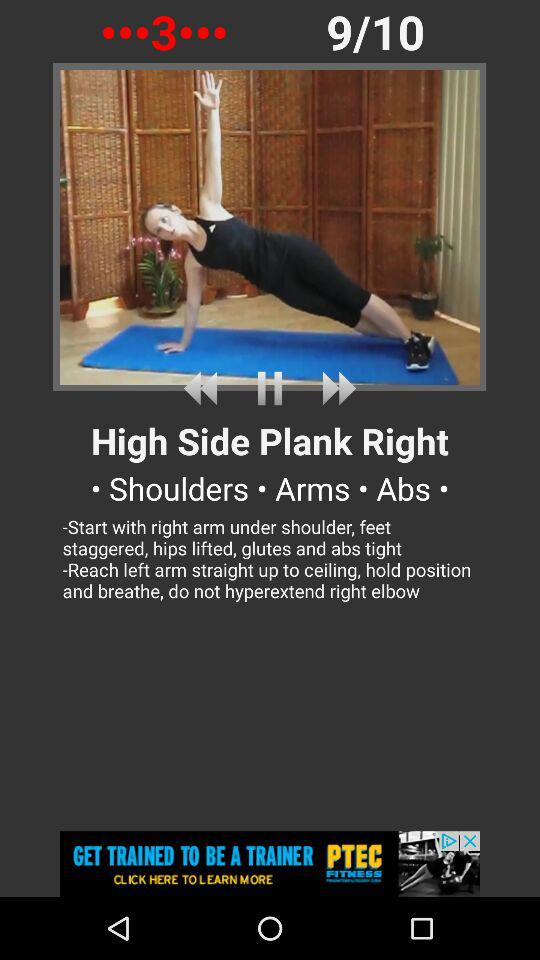What is the total count of exercises? The total number of exercises is 10. 